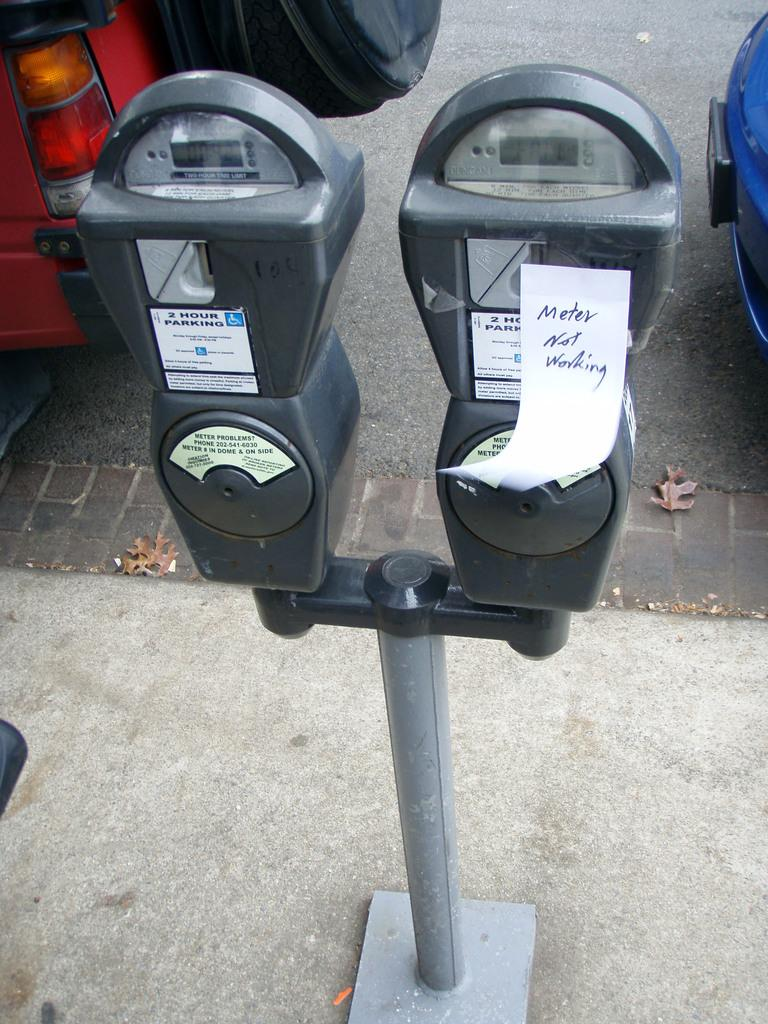<image>
Describe the image concisely. Two parking meters next to one another and one has a note that says Meter Not Working on it. 